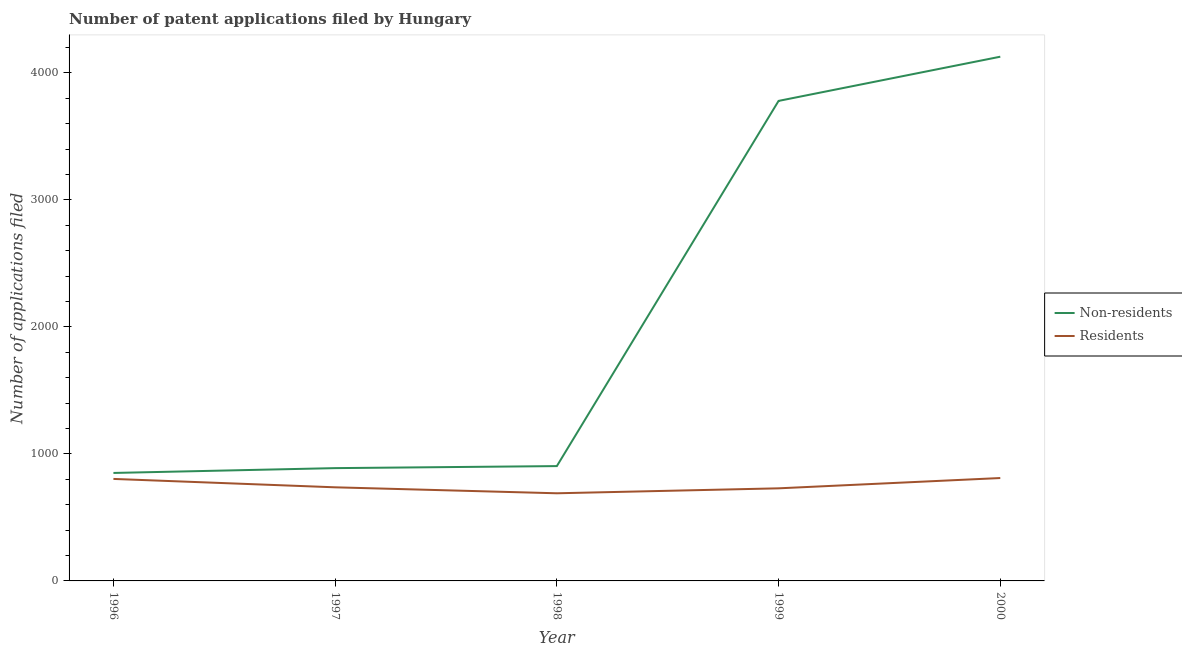Does the line corresponding to number of patent applications by residents intersect with the line corresponding to number of patent applications by non residents?
Give a very brief answer. No. What is the number of patent applications by residents in 1997?
Make the answer very short. 737. Across all years, what is the maximum number of patent applications by residents?
Ensure brevity in your answer.  810. Across all years, what is the minimum number of patent applications by non residents?
Your answer should be very brief. 850. What is the total number of patent applications by non residents in the graph?
Your answer should be compact. 1.05e+04. What is the difference between the number of patent applications by non residents in 1996 and that in 2000?
Keep it short and to the point. -3277. What is the difference between the number of patent applications by residents in 1999 and the number of patent applications by non residents in 1997?
Make the answer very short. -159. What is the average number of patent applications by residents per year?
Your answer should be very brief. 753.8. In the year 1996, what is the difference between the number of patent applications by non residents and number of patent applications by residents?
Make the answer very short. 47. In how many years, is the number of patent applications by non residents greater than 2800?
Your response must be concise. 2. What is the ratio of the number of patent applications by non residents in 1996 to that in 1997?
Give a very brief answer. 0.96. What is the difference between the highest and the second highest number of patent applications by non residents?
Your answer should be very brief. 348. What is the difference between the highest and the lowest number of patent applications by residents?
Provide a succinct answer. 120. Is the number of patent applications by residents strictly greater than the number of patent applications by non residents over the years?
Your answer should be very brief. No. Is the number of patent applications by residents strictly less than the number of patent applications by non residents over the years?
Offer a terse response. Yes. How many years are there in the graph?
Offer a terse response. 5. What is the difference between two consecutive major ticks on the Y-axis?
Provide a short and direct response. 1000. Does the graph contain grids?
Your answer should be compact. No. How are the legend labels stacked?
Ensure brevity in your answer.  Vertical. What is the title of the graph?
Your answer should be compact. Number of patent applications filed by Hungary. What is the label or title of the X-axis?
Your answer should be compact. Year. What is the label or title of the Y-axis?
Your answer should be compact. Number of applications filed. What is the Number of applications filed in Non-residents in 1996?
Your answer should be very brief. 850. What is the Number of applications filed of Residents in 1996?
Give a very brief answer. 803. What is the Number of applications filed of Non-residents in 1997?
Give a very brief answer. 888. What is the Number of applications filed of Residents in 1997?
Give a very brief answer. 737. What is the Number of applications filed in Non-residents in 1998?
Your answer should be very brief. 904. What is the Number of applications filed in Residents in 1998?
Your answer should be compact. 690. What is the Number of applications filed of Non-residents in 1999?
Offer a very short reply. 3779. What is the Number of applications filed in Residents in 1999?
Make the answer very short. 729. What is the Number of applications filed in Non-residents in 2000?
Your response must be concise. 4127. What is the Number of applications filed of Residents in 2000?
Ensure brevity in your answer.  810. Across all years, what is the maximum Number of applications filed in Non-residents?
Your answer should be very brief. 4127. Across all years, what is the maximum Number of applications filed in Residents?
Provide a succinct answer. 810. Across all years, what is the minimum Number of applications filed in Non-residents?
Your response must be concise. 850. Across all years, what is the minimum Number of applications filed of Residents?
Ensure brevity in your answer.  690. What is the total Number of applications filed of Non-residents in the graph?
Your response must be concise. 1.05e+04. What is the total Number of applications filed in Residents in the graph?
Your response must be concise. 3769. What is the difference between the Number of applications filed of Non-residents in 1996 and that in 1997?
Ensure brevity in your answer.  -38. What is the difference between the Number of applications filed of Non-residents in 1996 and that in 1998?
Ensure brevity in your answer.  -54. What is the difference between the Number of applications filed of Residents in 1996 and that in 1998?
Keep it short and to the point. 113. What is the difference between the Number of applications filed in Non-residents in 1996 and that in 1999?
Your answer should be compact. -2929. What is the difference between the Number of applications filed in Non-residents in 1996 and that in 2000?
Offer a very short reply. -3277. What is the difference between the Number of applications filed of Non-residents in 1997 and that in 1999?
Your answer should be compact. -2891. What is the difference between the Number of applications filed in Residents in 1997 and that in 1999?
Make the answer very short. 8. What is the difference between the Number of applications filed in Non-residents in 1997 and that in 2000?
Offer a very short reply. -3239. What is the difference between the Number of applications filed of Residents in 1997 and that in 2000?
Give a very brief answer. -73. What is the difference between the Number of applications filed of Non-residents in 1998 and that in 1999?
Offer a very short reply. -2875. What is the difference between the Number of applications filed of Residents in 1998 and that in 1999?
Your response must be concise. -39. What is the difference between the Number of applications filed in Non-residents in 1998 and that in 2000?
Provide a succinct answer. -3223. What is the difference between the Number of applications filed of Residents in 1998 and that in 2000?
Your answer should be compact. -120. What is the difference between the Number of applications filed of Non-residents in 1999 and that in 2000?
Ensure brevity in your answer.  -348. What is the difference between the Number of applications filed of Residents in 1999 and that in 2000?
Offer a very short reply. -81. What is the difference between the Number of applications filed in Non-residents in 1996 and the Number of applications filed in Residents in 1997?
Your response must be concise. 113. What is the difference between the Number of applications filed of Non-residents in 1996 and the Number of applications filed of Residents in 1998?
Provide a short and direct response. 160. What is the difference between the Number of applications filed in Non-residents in 1996 and the Number of applications filed in Residents in 1999?
Provide a short and direct response. 121. What is the difference between the Number of applications filed of Non-residents in 1996 and the Number of applications filed of Residents in 2000?
Ensure brevity in your answer.  40. What is the difference between the Number of applications filed in Non-residents in 1997 and the Number of applications filed in Residents in 1998?
Make the answer very short. 198. What is the difference between the Number of applications filed in Non-residents in 1997 and the Number of applications filed in Residents in 1999?
Your response must be concise. 159. What is the difference between the Number of applications filed of Non-residents in 1997 and the Number of applications filed of Residents in 2000?
Provide a succinct answer. 78. What is the difference between the Number of applications filed of Non-residents in 1998 and the Number of applications filed of Residents in 1999?
Offer a very short reply. 175. What is the difference between the Number of applications filed in Non-residents in 1998 and the Number of applications filed in Residents in 2000?
Provide a short and direct response. 94. What is the difference between the Number of applications filed in Non-residents in 1999 and the Number of applications filed in Residents in 2000?
Give a very brief answer. 2969. What is the average Number of applications filed of Non-residents per year?
Keep it short and to the point. 2109.6. What is the average Number of applications filed in Residents per year?
Your answer should be very brief. 753.8. In the year 1997, what is the difference between the Number of applications filed of Non-residents and Number of applications filed of Residents?
Your answer should be compact. 151. In the year 1998, what is the difference between the Number of applications filed in Non-residents and Number of applications filed in Residents?
Offer a terse response. 214. In the year 1999, what is the difference between the Number of applications filed in Non-residents and Number of applications filed in Residents?
Make the answer very short. 3050. In the year 2000, what is the difference between the Number of applications filed in Non-residents and Number of applications filed in Residents?
Your answer should be very brief. 3317. What is the ratio of the Number of applications filed of Non-residents in 1996 to that in 1997?
Your answer should be compact. 0.96. What is the ratio of the Number of applications filed in Residents in 1996 to that in 1997?
Provide a succinct answer. 1.09. What is the ratio of the Number of applications filed of Non-residents in 1996 to that in 1998?
Provide a short and direct response. 0.94. What is the ratio of the Number of applications filed of Residents in 1996 to that in 1998?
Offer a very short reply. 1.16. What is the ratio of the Number of applications filed in Non-residents in 1996 to that in 1999?
Offer a very short reply. 0.22. What is the ratio of the Number of applications filed of Residents in 1996 to that in 1999?
Give a very brief answer. 1.1. What is the ratio of the Number of applications filed in Non-residents in 1996 to that in 2000?
Offer a very short reply. 0.21. What is the ratio of the Number of applications filed of Non-residents in 1997 to that in 1998?
Offer a very short reply. 0.98. What is the ratio of the Number of applications filed of Residents in 1997 to that in 1998?
Your answer should be compact. 1.07. What is the ratio of the Number of applications filed of Non-residents in 1997 to that in 1999?
Provide a short and direct response. 0.23. What is the ratio of the Number of applications filed in Non-residents in 1997 to that in 2000?
Make the answer very short. 0.22. What is the ratio of the Number of applications filed of Residents in 1997 to that in 2000?
Your response must be concise. 0.91. What is the ratio of the Number of applications filed in Non-residents in 1998 to that in 1999?
Offer a very short reply. 0.24. What is the ratio of the Number of applications filed in Residents in 1998 to that in 1999?
Offer a very short reply. 0.95. What is the ratio of the Number of applications filed of Non-residents in 1998 to that in 2000?
Keep it short and to the point. 0.22. What is the ratio of the Number of applications filed in Residents in 1998 to that in 2000?
Give a very brief answer. 0.85. What is the ratio of the Number of applications filed of Non-residents in 1999 to that in 2000?
Make the answer very short. 0.92. What is the difference between the highest and the second highest Number of applications filed in Non-residents?
Provide a short and direct response. 348. What is the difference between the highest and the lowest Number of applications filed in Non-residents?
Give a very brief answer. 3277. What is the difference between the highest and the lowest Number of applications filed in Residents?
Offer a terse response. 120. 